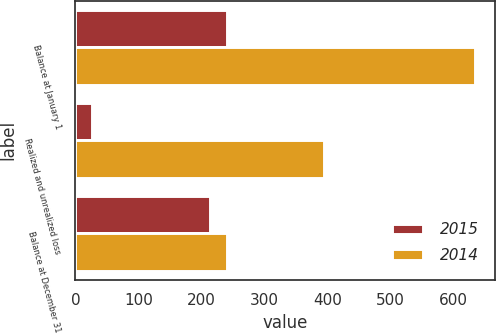<chart> <loc_0><loc_0><loc_500><loc_500><stacked_bar_chart><ecel><fcel>Balance at January 1<fcel>Realized and unrealized loss<fcel>Balance at December 31<nl><fcel>2015<fcel>240<fcel>26<fcel>214<nl><fcel>2014<fcel>635<fcel>395<fcel>240<nl></chart> 